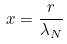<formula> <loc_0><loc_0><loc_500><loc_500>x = \frac { r } { \lambda _ { N } }</formula> 